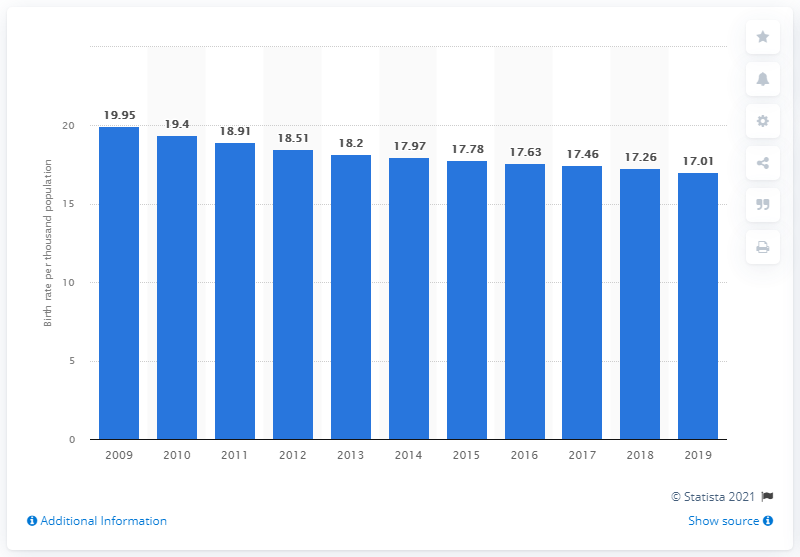Specify some key components in this picture. In 2019, the crude birth rate in Bhutan was 17.01. 